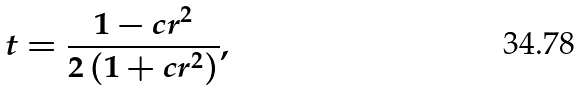<formula> <loc_0><loc_0><loc_500><loc_500>t = \frac { 1 - c r ^ { 2 } } { 2 \left ( 1 + c r ^ { 2 } \right ) } ,</formula> 